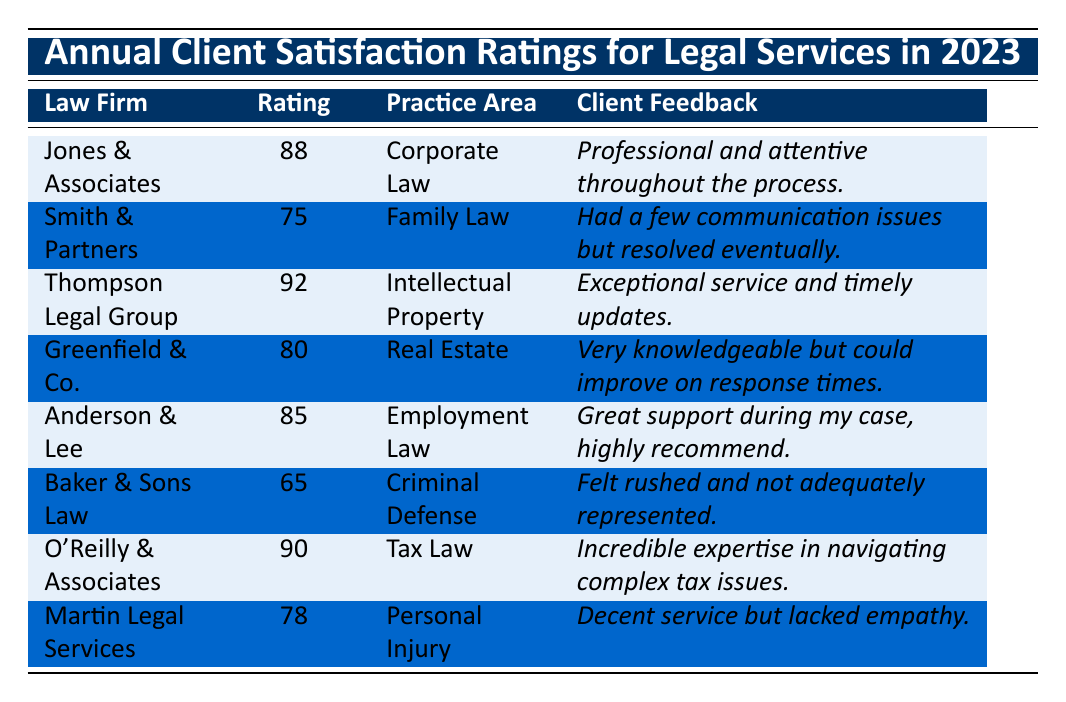What is the satisfaction rating of O'Reilly & Associates? The table shows that the satisfaction rating for O'Reilly & Associates is listed directly under the "Rating" column. It is 90.
Answer: 90 Which law firm has the highest satisfaction rating? By comparing the ratings in the table, Thompson Legal Group has the highest rating of 92.
Answer: Thompson Legal Group What is the satisfaction rating difference between Baker & Sons Law and Greenfield & Co.? The satisfaction rating for Baker & Sons Law is 65 and for Greenfield & Co. it is 80. The difference is 80 - 65 = 15.
Answer: 15 Did any law firm receive a satisfaction rating below 70? Yes, Baker & Sons Law received a satisfaction rating of 65, which is below 70.
Answer: Yes What is the average satisfaction rating for all the law firms listed? To find the average, sum all ratings: (88 + 75 + 92 + 80 + 85 + 65 + 90 + 78) = 665. There are 8 law firms, so the average is 665 / 8 = 83.125.
Answer: 83.125 Which area of practice has the lowest client feedback score based on satisfaction ratings? By examining the ratings, Baker & Sons Law in Criminal Defense has the lowest rating at 65.
Answer: Criminal Defense Is the client feedback for O'Reilly & Associates positive? The feedback states "_Incredible expertise in navigating complex tax issues_," which is a positive remark, indicating client satisfaction.
Answer: Yes How many law firms have a satisfaction rating of 80 or above? The firms with ratings of 80 or above are: Jones & Associates (88), Thompson Legal Group (92), O'Reilly & Associates (90), and Anderson & Lee (85). This totals 4 firms.
Answer: 4 What percentage of law firms received a rating of 75 or above? There are 8 law firms in total, and 5 of them (Jones & Associates, Thompson Legal Group, O'Reilly & Associates, Anderson & Lee, and Greenfield & Co.) received ratings of 75 or above. So the percentage is (5/8) * 100 = 62.5%.
Answer: 62.5% Which law firm has the most detailed client feedback? The feedback for Thompson Legal Group is "_Exceptional service and timely updates_", which is specific about both service and communication, suggesting it is the most detailed.
Answer: Thompson Legal Group 